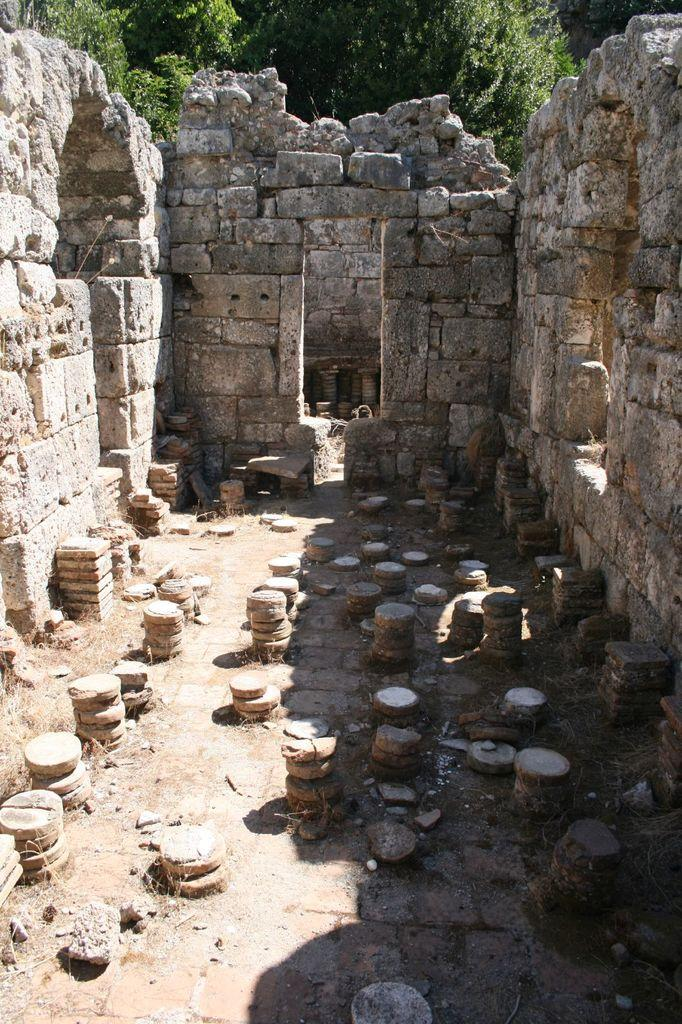What type of wall is visible in the image? There is a wall made with rocks in the image. What can be seen in the foreground of the image? In the foreground, there is a group of stones placed on the ground. What is visible in the background of the image? In the background, there is a tree visible. Can you hear the group of stones laughing in the image? There is no sound or laughter present in the image; it is a still image of a wall, stones, and a tree. Is there an alley visible in the image? There is no alley present in the image; it features a wall made with rocks, a group of stones in the foreground, and a tree in the background. 